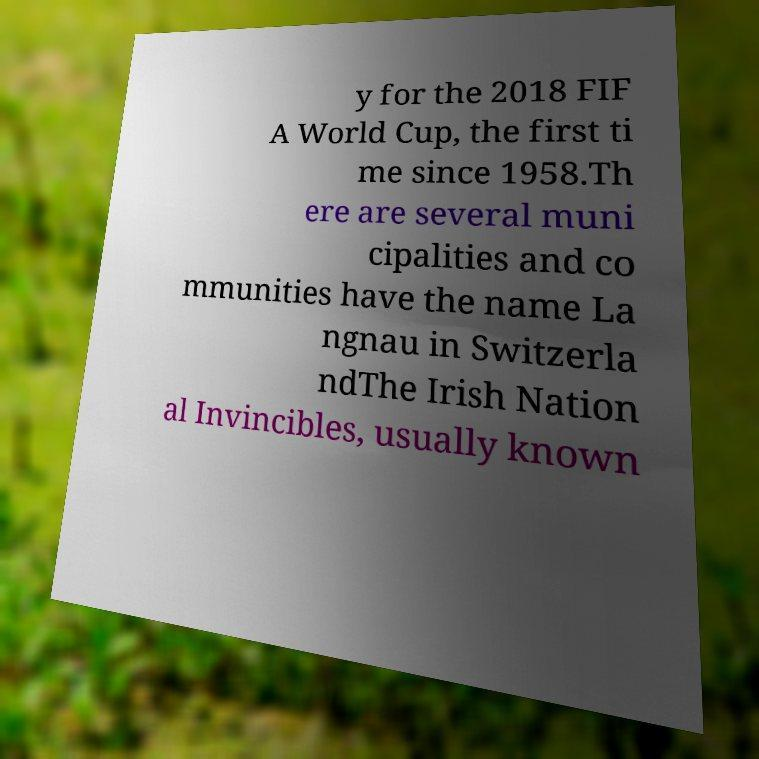Can you accurately transcribe the text from the provided image for me? y for the 2018 FIF A World Cup, the first ti me since 1958.Th ere are several muni cipalities and co mmunities have the name La ngnau in Switzerla ndThe Irish Nation al Invincibles, usually known 